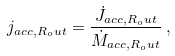Convert formula to latex. <formula><loc_0><loc_0><loc_500><loc_500>j _ { a c c , R _ { o } u t } = \frac { \dot { J } _ { a c c , R _ { o } u t } } { \dot { M } _ { a c c , R _ { o } u t } } \, ,</formula> 